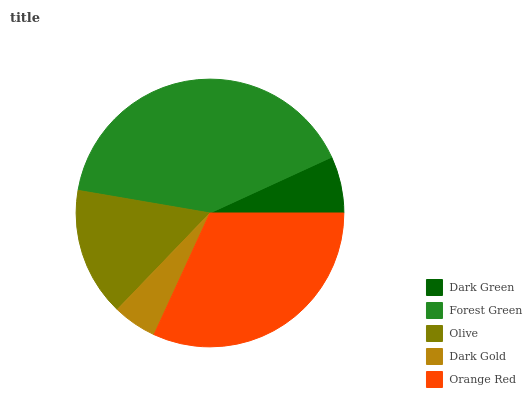Is Dark Gold the minimum?
Answer yes or no. Yes. Is Forest Green the maximum?
Answer yes or no. Yes. Is Olive the minimum?
Answer yes or no. No. Is Olive the maximum?
Answer yes or no. No. Is Forest Green greater than Olive?
Answer yes or no. Yes. Is Olive less than Forest Green?
Answer yes or no. Yes. Is Olive greater than Forest Green?
Answer yes or no. No. Is Forest Green less than Olive?
Answer yes or no. No. Is Olive the high median?
Answer yes or no. Yes. Is Olive the low median?
Answer yes or no. Yes. Is Dark Gold the high median?
Answer yes or no. No. Is Forest Green the low median?
Answer yes or no. No. 